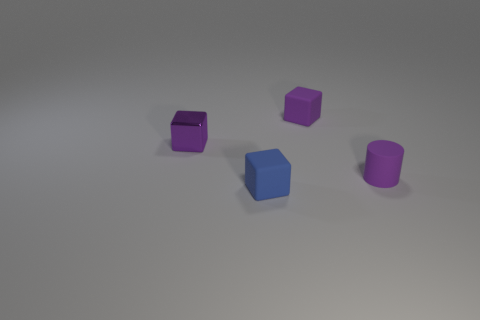Is the number of small purple matte things that are to the left of the small purple cylinder greater than the number of small objects that are on the right side of the tiny purple metal block?
Provide a short and direct response. No. What is the material of the thing that is both in front of the small purple metal cube and behind the blue matte block?
Offer a very short reply. Rubber. Is the tiny blue matte object the same shape as the metallic object?
Ensure brevity in your answer.  Yes. Is there any other thing that has the same size as the purple cylinder?
Give a very brief answer. Yes. There is a shiny object; how many rubber objects are to the left of it?
Provide a short and direct response. 0. Does the matte object that is in front of the purple cylinder have the same size as the small purple metallic block?
Offer a very short reply. Yes. There is another small shiny thing that is the same shape as the small blue thing; what is its color?
Your answer should be very brief. Purple. Are there any other things that have the same shape as the blue thing?
Ensure brevity in your answer.  Yes. There is a thing to the right of the purple matte block; what is its shape?
Provide a short and direct response. Cylinder. What number of blue objects have the same shape as the purple metallic object?
Ensure brevity in your answer.  1. 